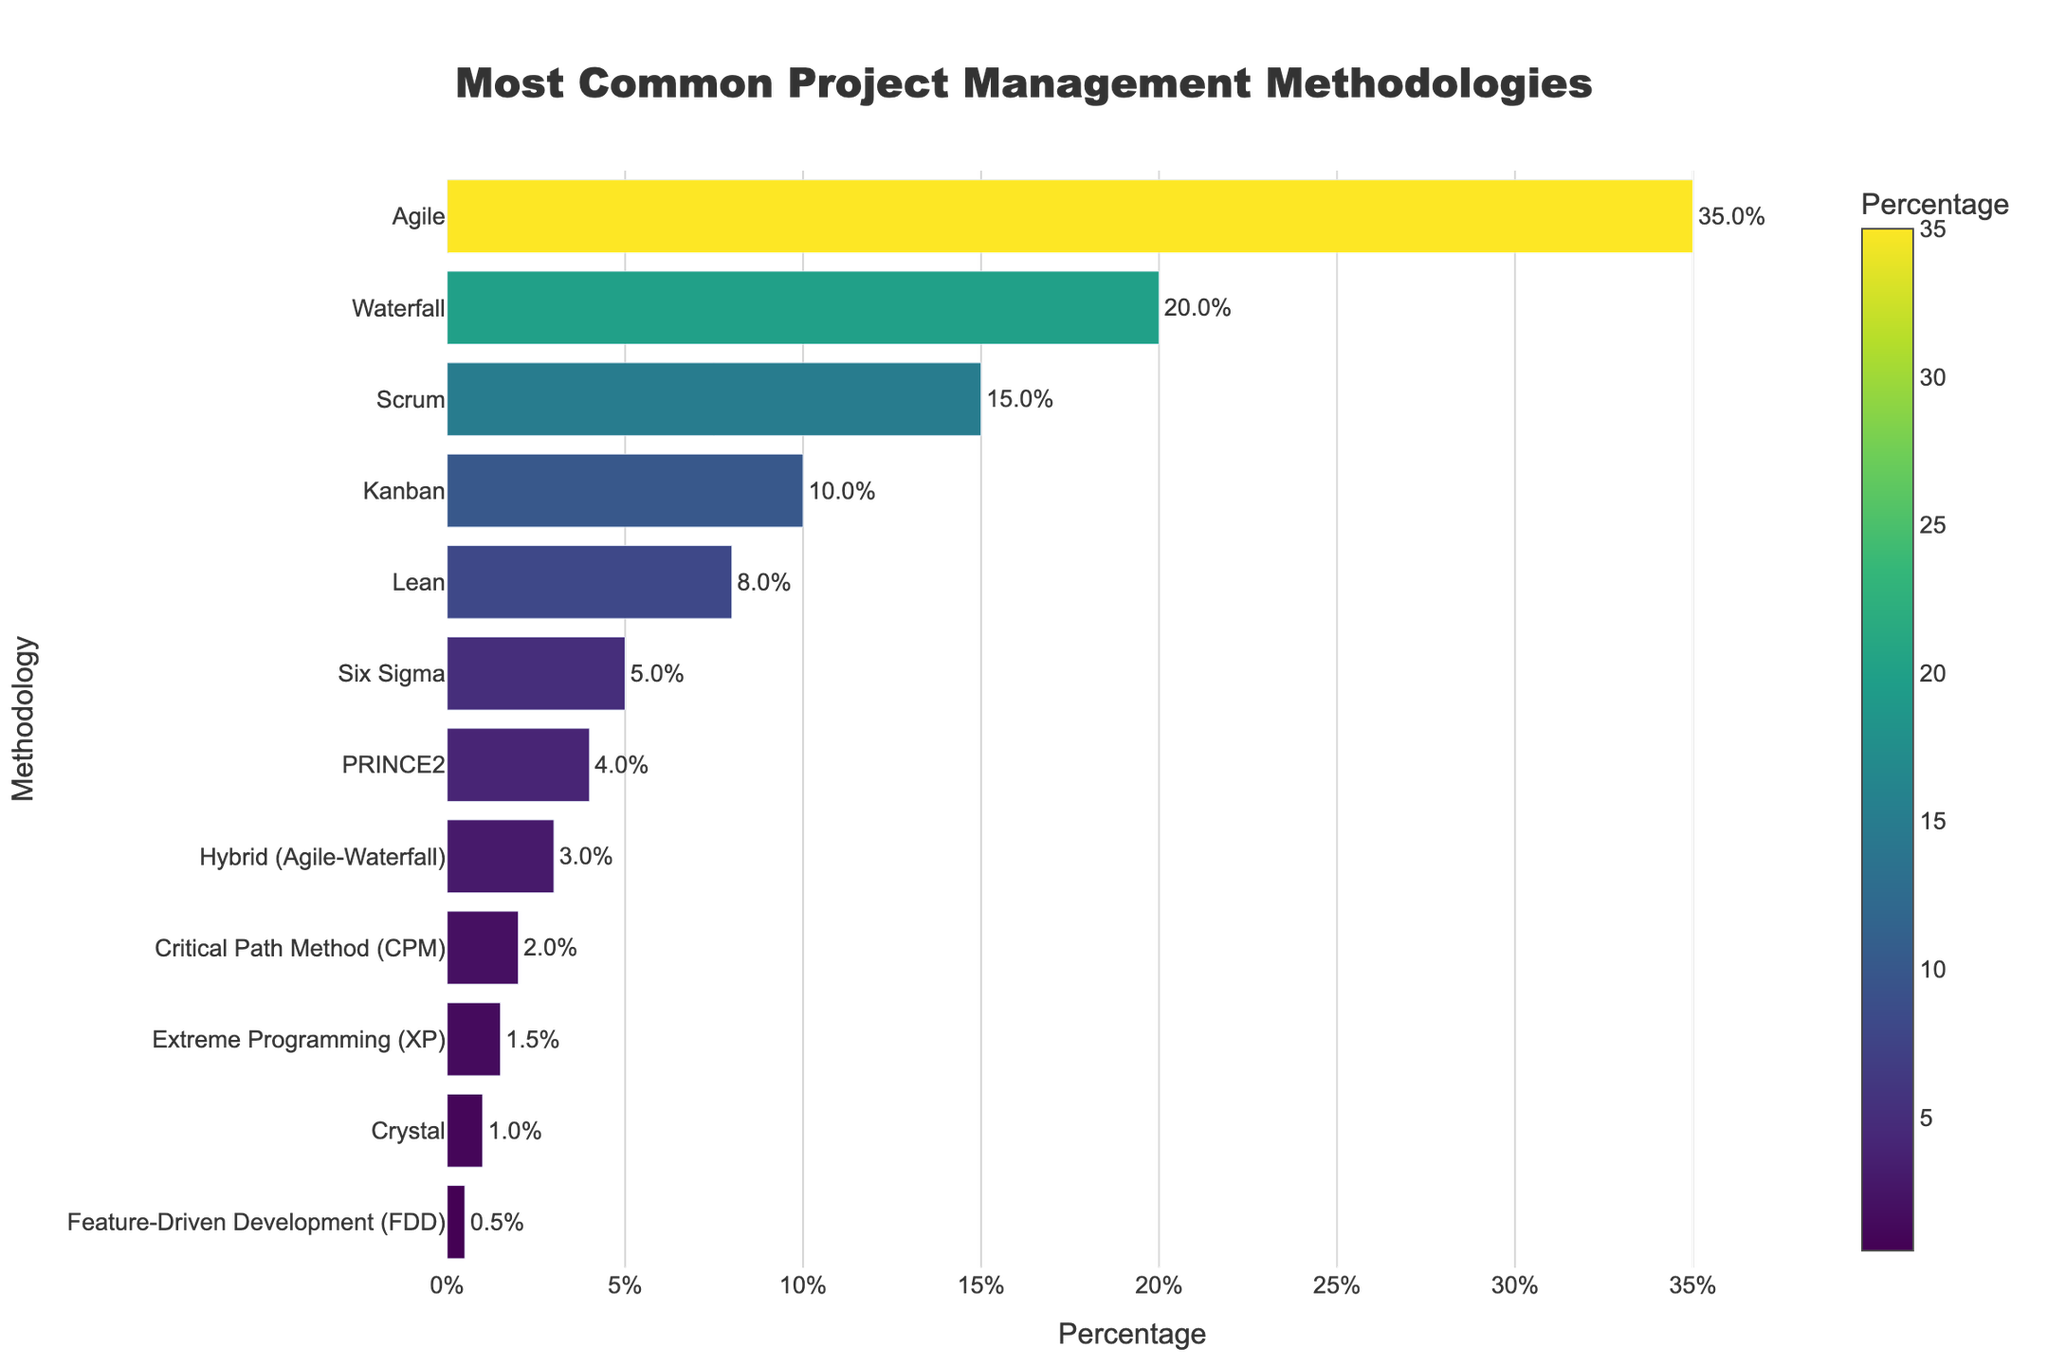Which project management methodology is the most commonly used across industries according to the figure? The figure ranks methodologies from highest to lowest based on their percentage usage. The tallest bar represents the methodology with the highest usage.
Answer: Agile How much more popular is Agile compared to Waterfall? By looking at the length of the bars, Agile is at 35% and Waterfall is at 20%. The difference is calculated as 35% - 20%.
Answer: 15% What is the combined percentage for Scrum, Kanban, and Lean methodologies? Summing up the percentages of the three methodologies: Scrum (15%) + Kanban (10%) + Lean (8%).
Answer: 33% Which is used more frequently: PRINCE2 or Six Sigma? By comparing the lengths of the bars, Six Sigma has a percentage of 5%, while PRINCE2 has 4%. Six Sigma has a longer bar.
Answer: Six Sigma What percentage of industries use methodologies classified as Agile or Hybrid (Agile-Waterfall)? Combining the percentages of Agile (35%) and Hybrid (3%) methodologies: 35% + 3%.
Answer: 38% How does the popularity of Critical Path Method (CPM) compare to Extreme Programming (XP)? CPM has a bar representing 2%, while XP has a bar representing 1.5%. CPM is thus more popular than XP.
Answer: CPM is more popular Is the combined usage of the least common methodologies (Crystal, Feature-Driven Development) greater than the usage of Lean methodology? Summing the percentages of Crystal (1%) and Feature-Driven Development (0.5%): 1% + 0.5% = 1.5%, and comparing to Lean's 8%. 1.5% is less than 8%.
Answer: No Which methodologies have usage percentages below 5%? Identifying bars shorter than the 5% marker: Six Sigma (5% - equal), PRINCE2 (4%), Hybrid (Agile-Waterfall) (3%), Critical Path Method (CPM) (2%), Extreme Programming (XP) (1.5%), Crystal (1%), and Feature-Driven Development (0.5%).
Answer: PRINCE2, Hybrid (Agile-Waterfall), CPM, XP, Crystal, FDD What is the total percentage of industries using Agile, Waterfall, and Six Sigma methodologies combined? Summing the percentages of Agile (35%), Waterfall (20%), and Six Sigma (5%): 35% + 20% + 5%.
Answer: 60% Which methodology shows a percentage that is half of Kanban's usage? Kanban is at 10%. Half of Kanban's usage is 10% / 2 = 5%. Cross-referencing, Six Sigma shows a 5% usage.
Answer: Six Sigma 